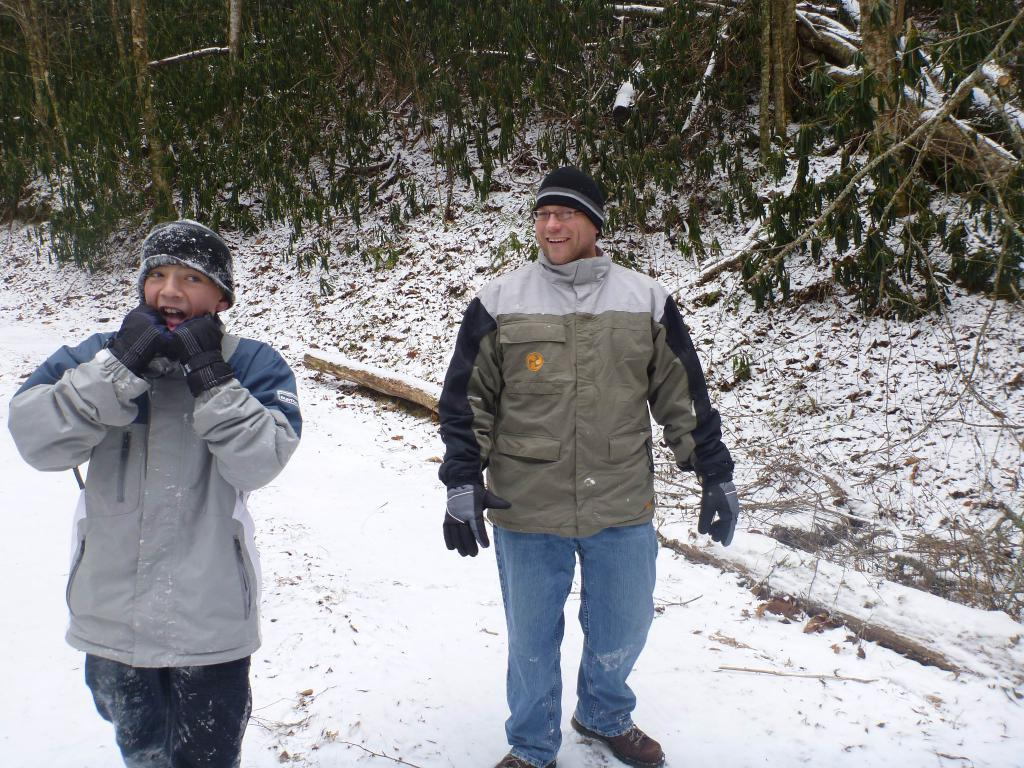How many people are in the image? There are two people standing in the image. What can be seen in the background of the image? There are trees visible in the background of the image. What is the ground made of in the image? There is snow at the bottom of the image. Can you describe any specific objects in the image? There is a tree branch in the image. What type of copper object is being used by one of the people in the image? There is no copper object present in the image. What drink is one of the people holding in the image? There is no drink visible in the image. 